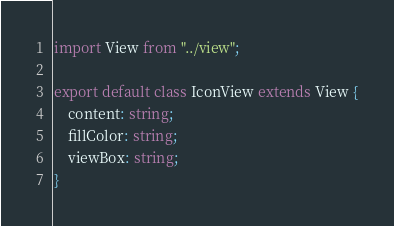Convert code to text. <code><loc_0><loc_0><loc_500><loc_500><_TypeScript_>import View from "../view";

export default class IconView extends View {
    content: string;
    fillColor: string;
    viewBox: string;
}
</code> 